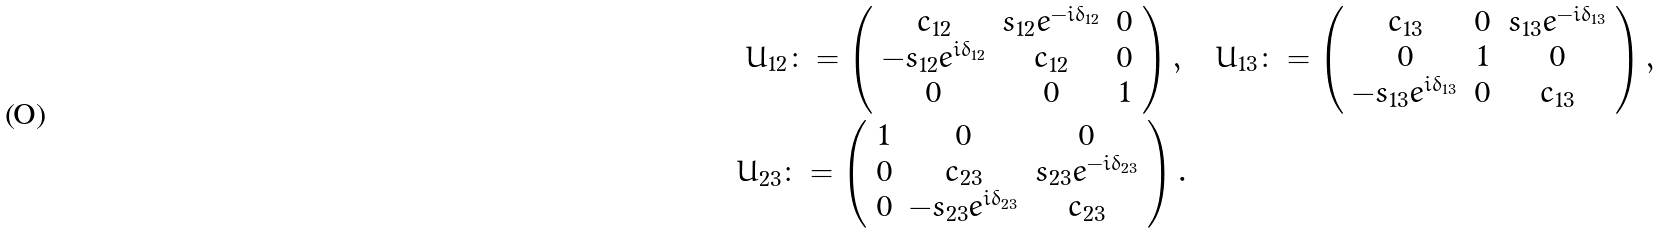<formula> <loc_0><loc_0><loc_500><loc_500>U _ { 1 2 } \colon = \left ( \begin{array} { c c c } c _ { 1 2 } & s _ { 1 2 } e ^ { - i \delta _ { 1 2 } } & 0 \\ - s _ { 1 2 } e ^ { i \delta _ { 1 2 } } & c _ { 1 2 } & 0 \\ 0 & 0 & 1 \end{array} \right ) , \, & \quad U _ { 1 3 } \colon = \left ( \begin{array} { c c c } c _ { 1 3 } & 0 & s _ { 1 3 } e ^ { - i \delta _ { 1 3 } } \\ 0 & 1 & 0 \\ - s _ { 1 3 } e ^ { i \delta _ { 1 3 } } & 0 & c _ { 1 3 } \end{array} \right ) , \\ U _ { 2 3 } \colon = \left ( \begin{array} { c c c } 1 & 0 & 0 \\ 0 & c _ { 2 3 } & s _ { 2 3 } e ^ { - i \delta _ { 2 3 } } \\ 0 & - s _ { 2 3 } e ^ { i \delta _ { 2 3 } } & c _ { 2 3 } \end{array} \right ) . &</formula> 